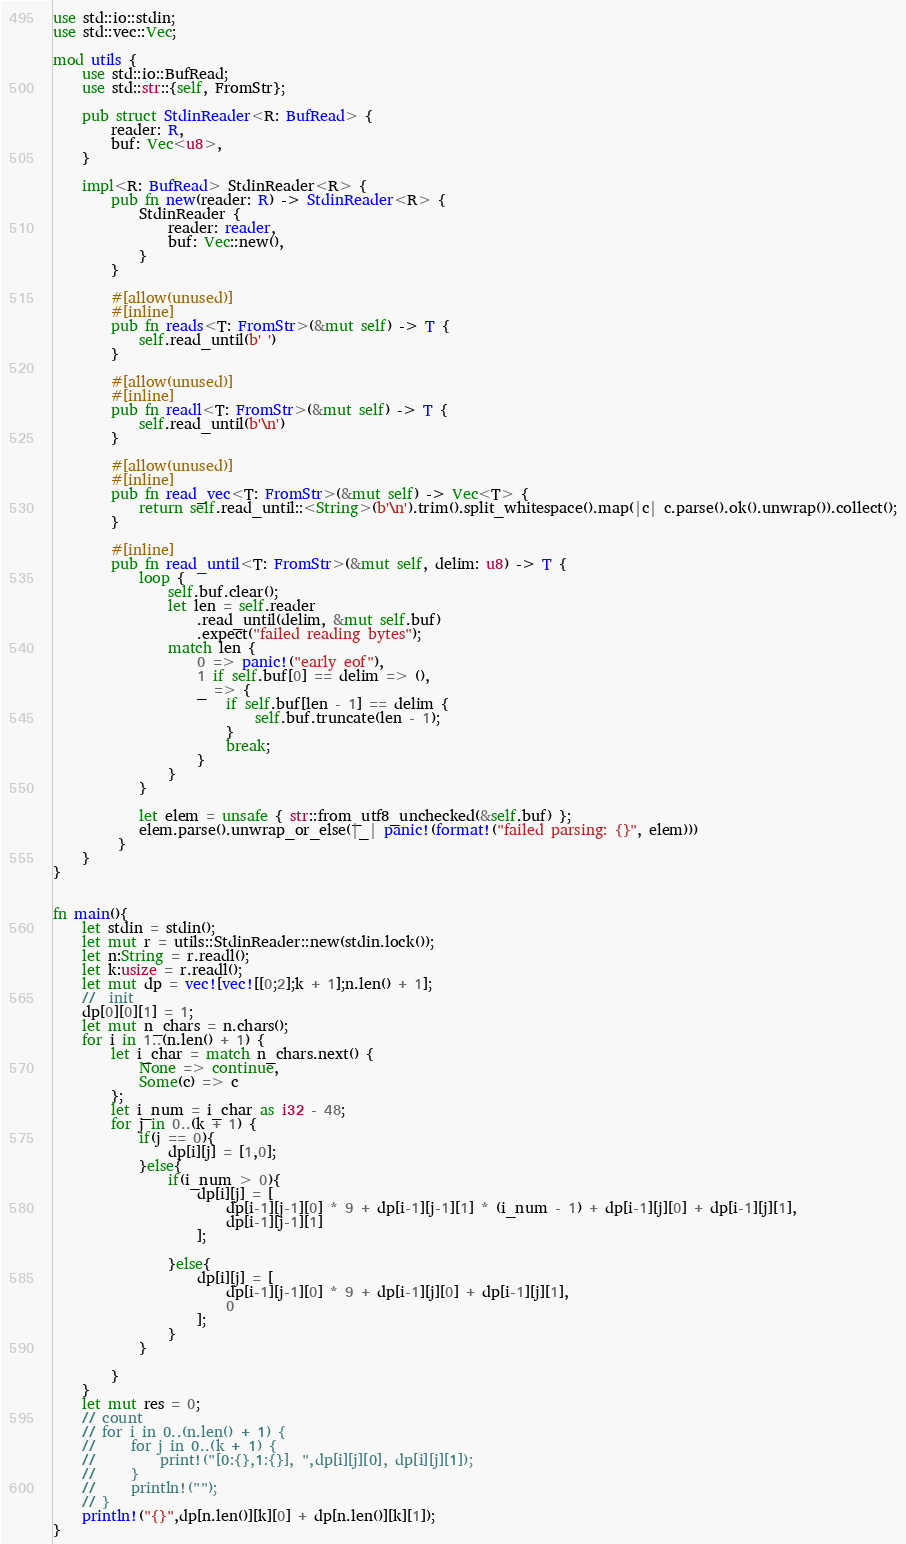<code> <loc_0><loc_0><loc_500><loc_500><_Rust_>use std::io::stdin;
use std::vec::Vec;

mod utils {
    use std::io::BufRead;
    use std::str::{self, FromStr};

    pub struct StdinReader<R: BufRead> {
        reader: R,
        buf: Vec<u8>,
    }

    impl<R: BufRead> StdinReader<R> {
        pub fn new(reader: R) -> StdinReader<R> {
            StdinReader {
                reader: reader,
                buf: Vec::new(),
            }
        }

        #[allow(unused)]
        #[inline]
        pub fn reads<T: FromStr>(&mut self) -> T {
            self.read_until(b' ')
        }

        #[allow(unused)]
        #[inline]
        pub fn readl<T: FromStr>(&mut self) -> T {
            self.read_until(b'\n')
        }

        #[allow(unused)]
        #[inline]
        pub fn read_vec<T: FromStr>(&mut self) -> Vec<T> {
            return self.read_until::<String>(b'\n').trim().split_whitespace().map(|c| c.parse().ok().unwrap()).collect();
        }

        #[inline]
        pub fn read_until<T: FromStr>(&mut self, delim: u8) -> T {
            loop {
                self.buf.clear();
                let len = self.reader
                    .read_until(delim, &mut self.buf)
                    .expect("failed reading bytes");
                match len {
                    0 => panic!("early eof"),
                    1 if self.buf[0] == delim => (),
                    _ => {
                        if self.buf[len - 1] == delim {
                            self.buf.truncate(len - 1);
                        }
                        break;
                    }
                }
            }

            let elem = unsafe { str::from_utf8_unchecked(&self.buf) };
            elem.parse().unwrap_or_else(|_| panic!(format!("failed parsing: {}", elem)))
         }
    }
}


fn main(){
    let stdin = stdin();
    let mut r = utils::StdinReader::new(stdin.lock());
    let n:String = r.readl();
    let k:usize = r.readl();
    let mut dp = vec![vec![[0;2];k + 1];n.len() + 1];
    //  init
    dp[0][0][1] = 1;
    let mut n_chars = n.chars();
    for i in 1..(n.len() + 1) {
        let i_char = match n_chars.next() {
            None => continue,
            Some(c) => c
        };
        let i_num = i_char as i32 - 48;
        for j in 0..(k + 1) {
            if(j == 0){
                dp[i][j] = [1,0];
            }else{
                if(i_num > 0){
                    dp[i][j] = [
                        dp[i-1][j-1][0] * 9 + dp[i-1][j-1][1] * (i_num - 1) + dp[i-1][j][0] + dp[i-1][j][1],
                        dp[i-1][j-1][1]
                    ];

                }else{
                    dp[i][j] = [
                        dp[i-1][j-1][0] * 9 + dp[i-1][j][0] + dp[i-1][j][1],
                        0
                    ];
                }
            }

        }
    }
    let mut res = 0;
    // count
    // for i in 0..(n.len() + 1) {
    //     for j in 0..(k + 1) {
    //         print!("[0:{},1:{}], ",dp[i][j][0], dp[i][j][1]);
    //     }
    //     println!("");
    // }
    println!("{}",dp[n.len()][k][0] + dp[n.len()][k][1]);
}
</code> 